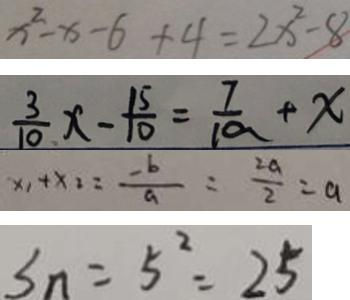Convert formula to latex. <formula><loc_0><loc_0><loc_500><loc_500>x ^ { 2 } - x - 6 + 4 = 2 x ^ { 2 } - 8 
 \frac { 3 } { 1 0 } x - \frac { 1 5 } { 1 0 } = \frac { 7 } { 1 0 } + x 
 x _ { 1 } + x _ { 2 } = \frac { - b } { a } = \frac { 2 a } { 2 } = a 
 S _ { n } = 5 ^ { 2 } = 2 5</formula> 